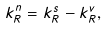<formula> <loc_0><loc_0><loc_500><loc_500>k _ { R } ^ { n } = k _ { R } ^ { s } - k _ { R } ^ { v } ,</formula> 